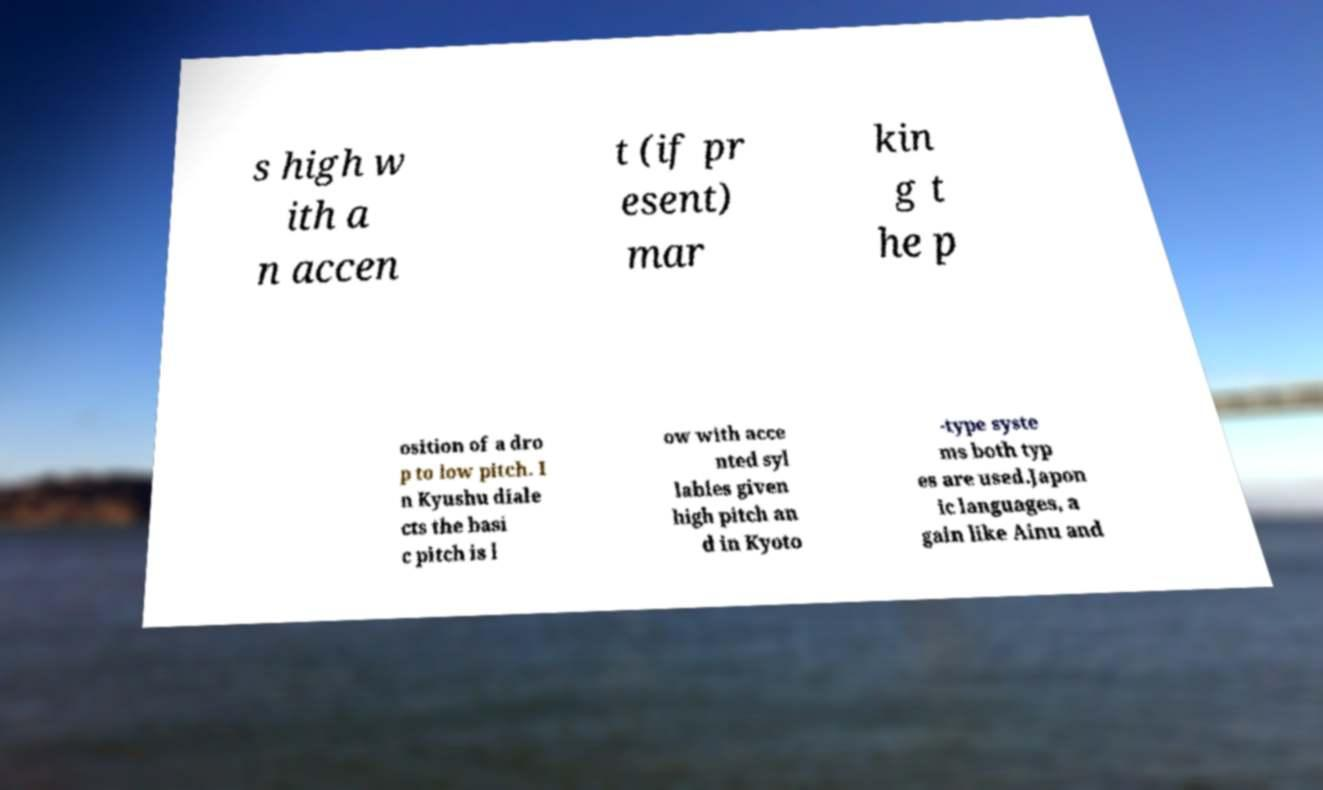What messages or text are displayed in this image? I need them in a readable, typed format. s high w ith a n accen t (if pr esent) mar kin g t he p osition of a dro p to low pitch. I n Kyushu diale cts the basi c pitch is l ow with acce nted syl lables given high pitch an d in Kyoto -type syste ms both typ es are used.Japon ic languages, a gain like Ainu and 